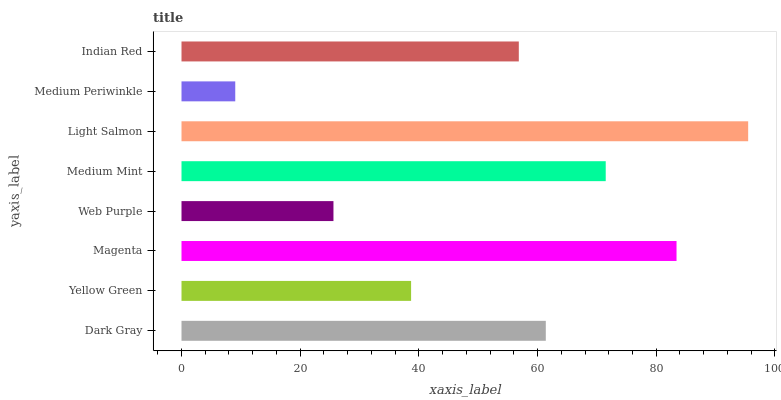Is Medium Periwinkle the minimum?
Answer yes or no. Yes. Is Light Salmon the maximum?
Answer yes or no. Yes. Is Yellow Green the minimum?
Answer yes or no. No. Is Yellow Green the maximum?
Answer yes or no. No. Is Dark Gray greater than Yellow Green?
Answer yes or no. Yes. Is Yellow Green less than Dark Gray?
Answer yes or no. Yes. Is Yellow Green greater than Dark Gray?
Answer yes or no. No. Is Dark Gray less than Yellow Green?
Answer yes or no. No. Is Dark Gray the high median?
Answer yes or no. Yes. Is Indian Red the low median?
Answer yes or no. Yes. Is Medium Mint the high median?
Answer yes or no. No. Is Medium Mint the low median?
Answer yes or no. No. 